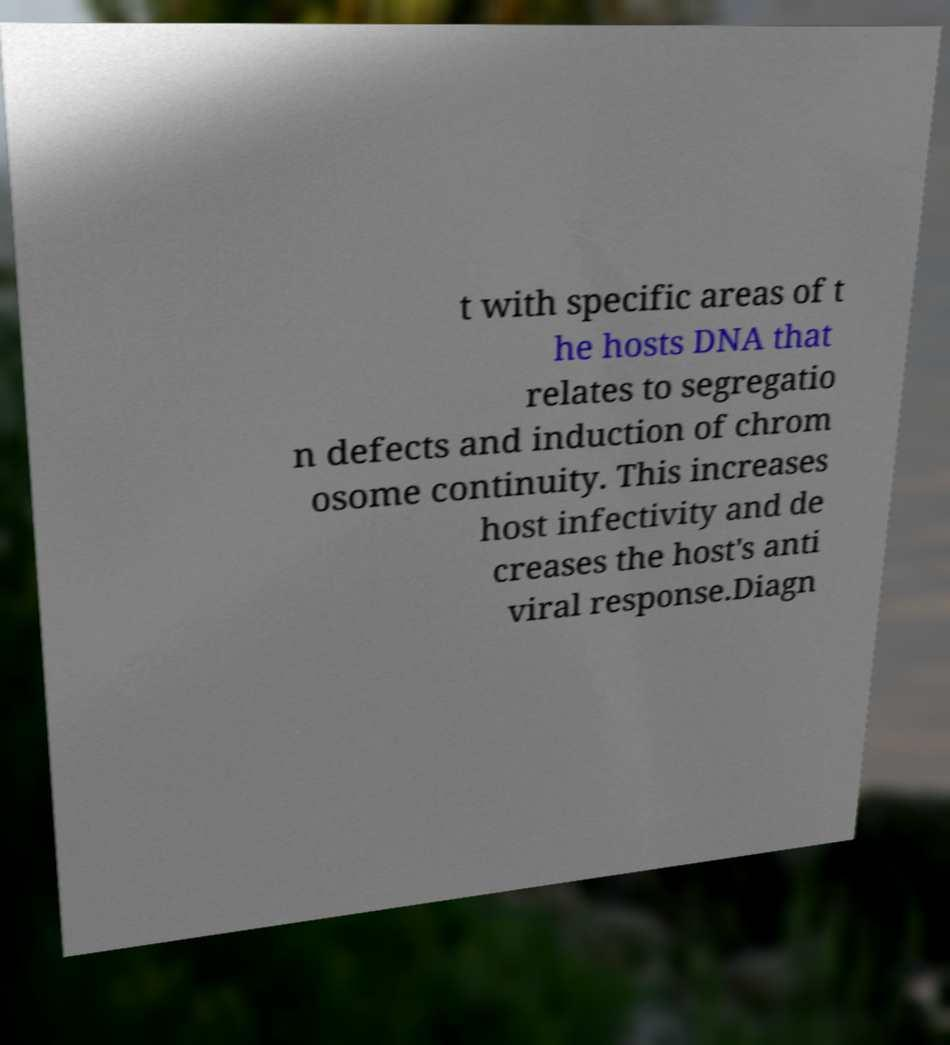Could you assist in decoding the text presented in this image and type it out clearly? t with specific areas of t he hosts DNA that relates to segregatio n defects and induction of chrom osome continuity. This increases host infectivity and de creases the host's anti viral response.Diagn 